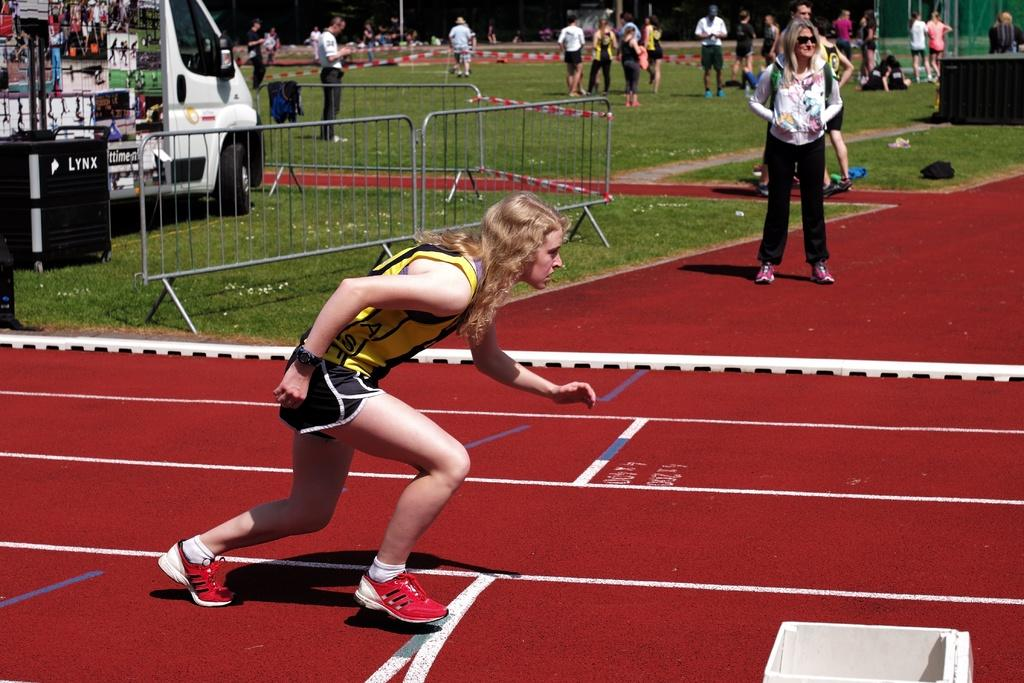<image>
Relay a brief, clear account of the picture shown. A woman prepares to run on a track in front of a LYNX container. 